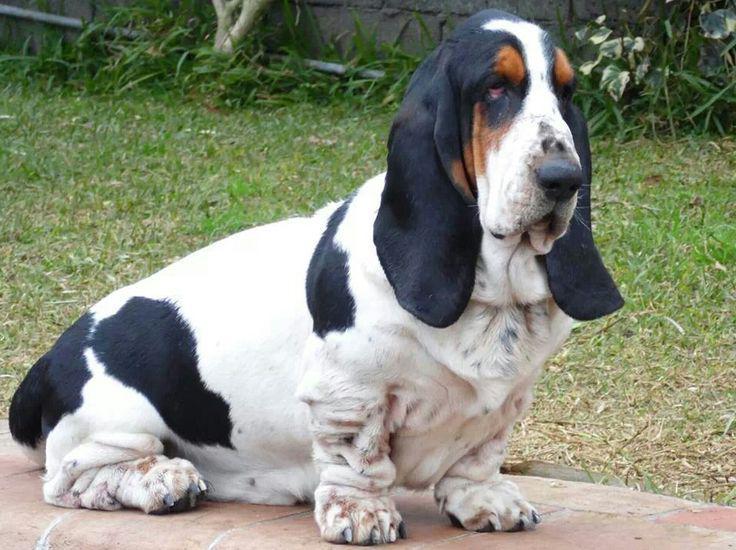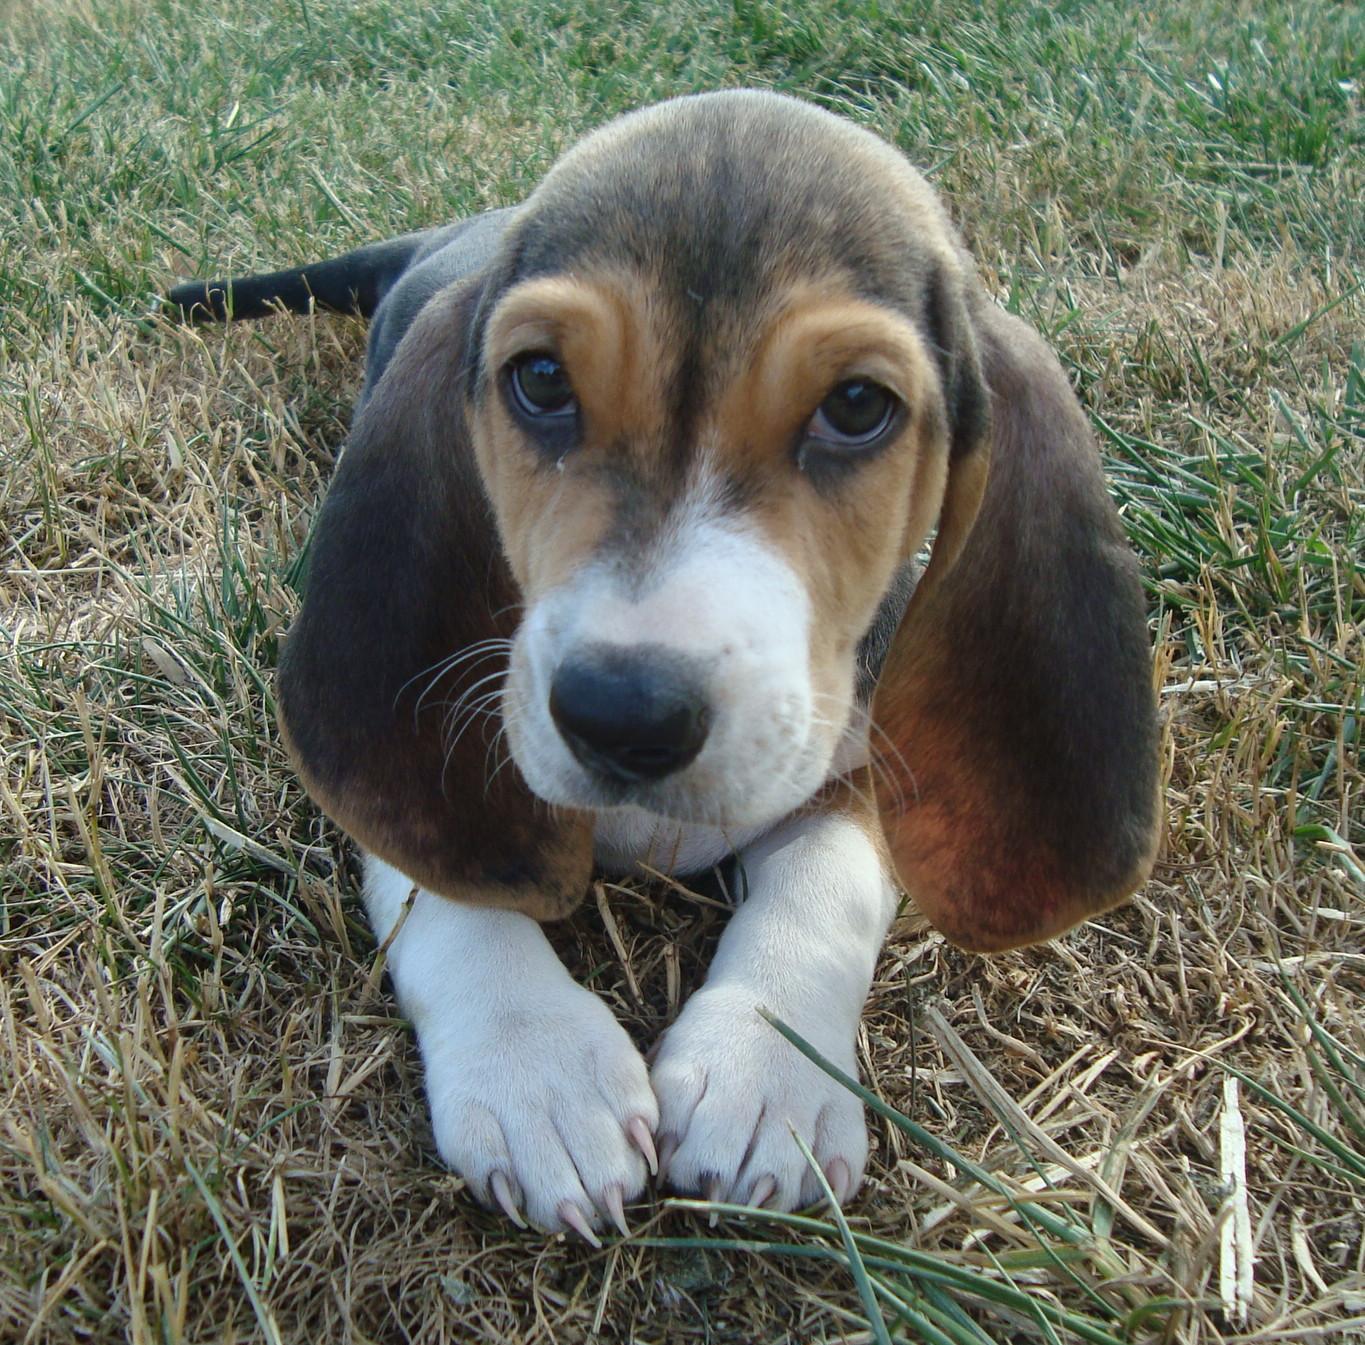The first image is the image on the left, the second image is the image on the right. For the images shown, is this caption "In one image there is two basset hounds outside standing on a brick walkway." true? Answer yes or no. No. The first image is the image on the left, the second image is the image on the right. Given the left and right images, does the statement "There are at most two dogs." hold true? Answer yes or no. Yes. 